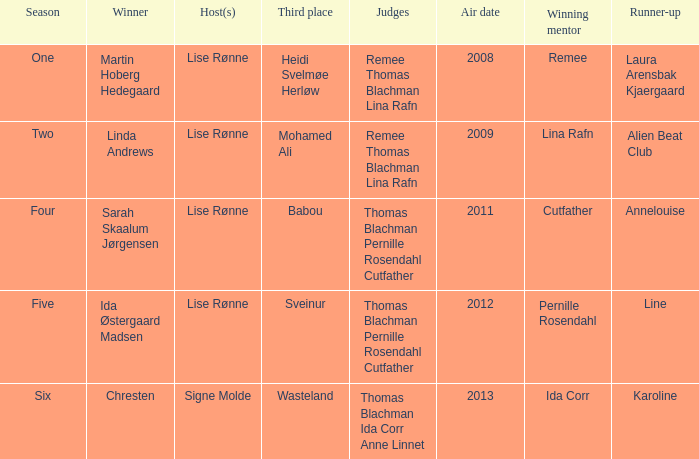Who was the runner-up when Mohamed Ali got third? Alien Beat Club. 